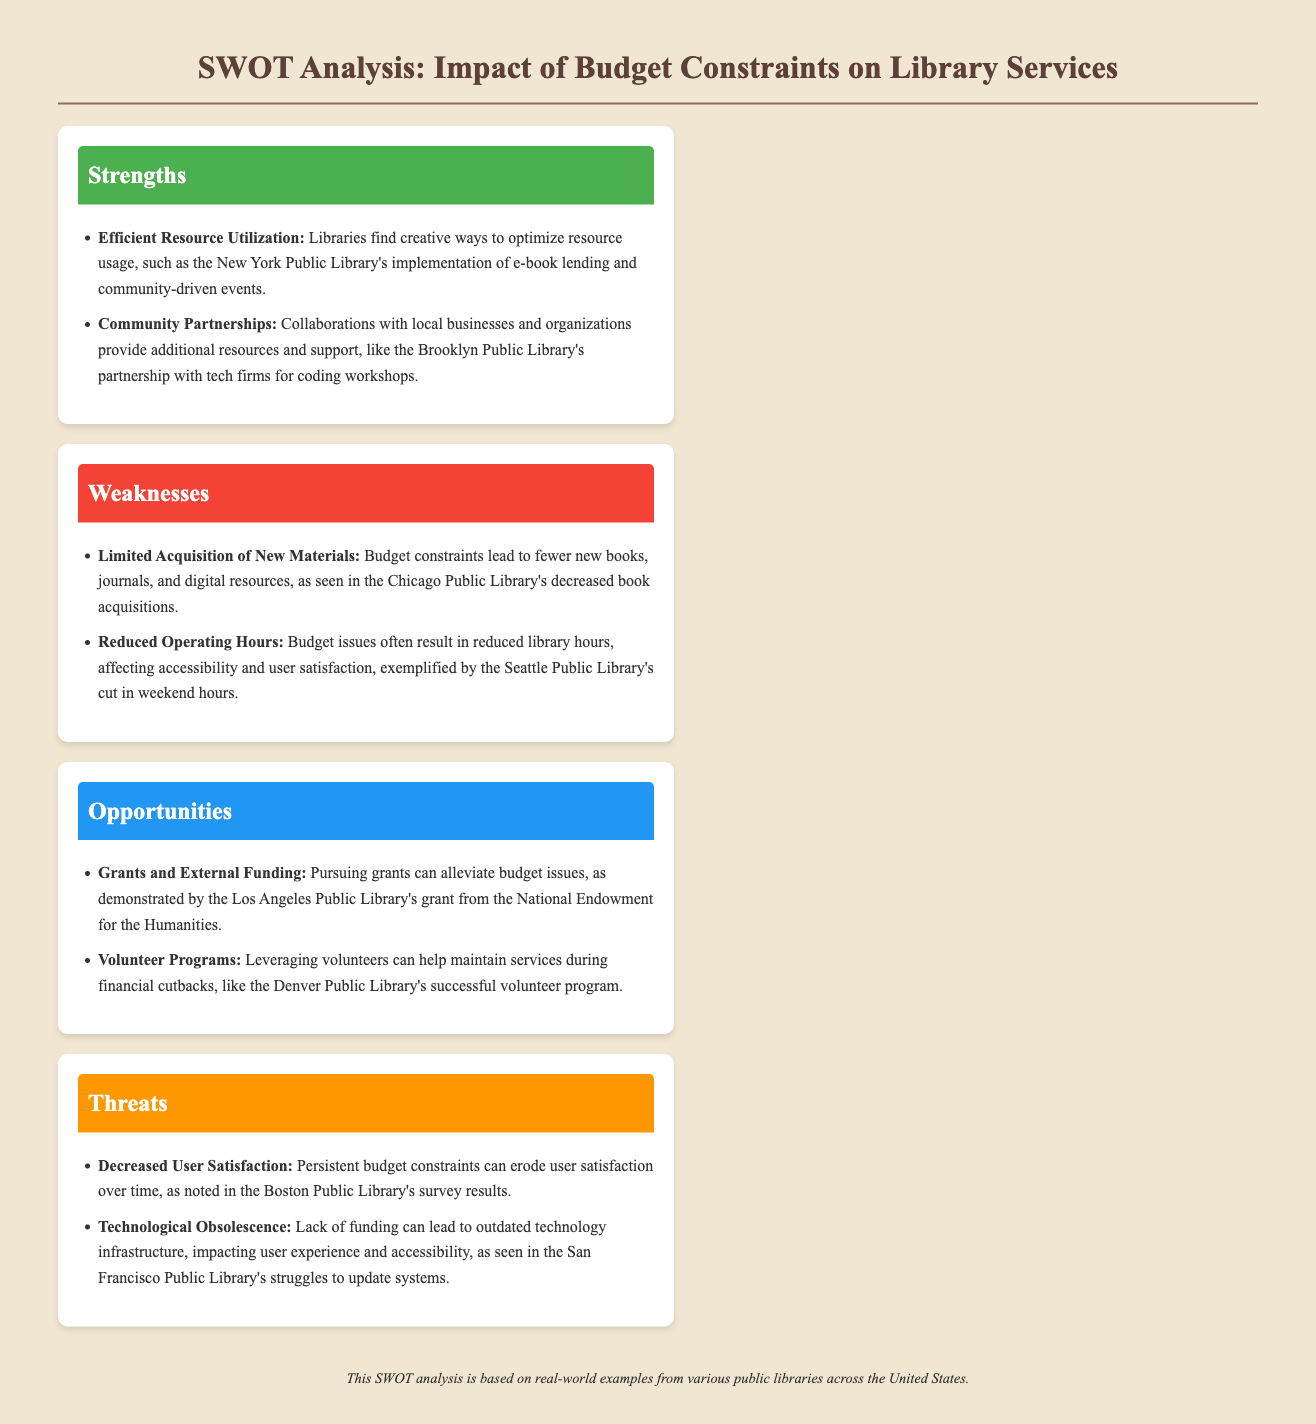What is one example of efficient resource utilization? The document states that libraries optimize resource usage through initiatives like the New York Public Library's implementation of e-book lending.
Answer: e-book lending What partnership is mentioned that supports library resources? The document notes that community partnerships, such as the Brooklyn Public Library's with tech firms, provide additional resources and support.
Answer: tech firms What effect do budget constraints have on new material acquisition? The document mentions that budget constraints lead to fewer new books, journals, and digital resources in libraries.
Answer: fewer new materials What is one consequence of reduced operating hours? The document indicates that reduced operating hours affect accessibility and user satisfaction, exemplified by Seattle Public Library's weekend hour cuts.
Answer: user satisfaction What can be pursued to alleviate budget issues? According to the document, pursuing grants can help relieve budget issues for libraries.
Answer: grants What role do volunteers play during financial cutbacks? The document highlights that leveraging volunteers helps maintain services during financial cutbacks, as seen in Denver Public Library's program.
Answer: maintain services What is a threat related to user satisfaction? The document cites that persistent budget constraints can lead to decreased user satisfaction over time.
Answer: decreased user satisfaction What issue arises from a lack of funding regarding technology? The document states that lack of funding can lead to outdated technology infrastructure, impacting user experience.
Answer: outdated technology What type of document is this analysis? The content is structured as a SWOT analysis, focusing on strengths, weaknesses, opportunities, and threats.
Answer: SWOT analysis 